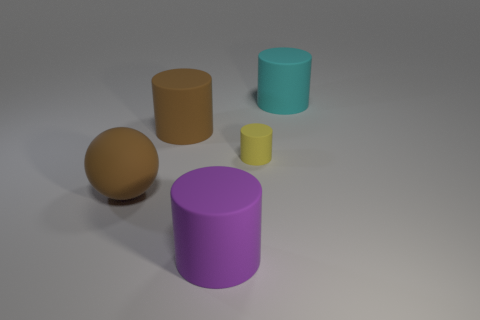Is there anything else that is the same size as the yellow matte object?
Ensure brevity in your answer.  No. Is there a tiny yellow thing that has the same shape as the large cyan thing?
Provide a succinct answer. Yes. Is the size of the matte cylinder on the right side of the yellow thing the same as the yellow thing?
Ensure brevity in your answer.  No. What size is the rubber cylinder that is behind the purple thing and to the left of the tiny matte cylinder?
Offer a very short reply. Large. How many other things are there of the same material as the yellow cylinder?
Ensure brevity in your answer.  4. What is the size of the brown thing in front of the tiny matte object?
Your response must be concise. Large. Do the matte ball and the tiny cylinder have the same color?
Offer a very short reply. No. How many large objects are either brown matte balls or purple rubber things?
Your answer should be very brief. 2. Is there any other thing of the same color as the tiny cylinder?
Ensure brevity in your answer.  No. There is a big cyan matte cylinder; are there any large purple cylinders in front of it?
Give a very brief answer. Yes. 